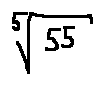Convert formula to latex. <formula><loc_0><loc_0><loc_500><loc_500>\sqrt { [ } 5 ] { 5 5 }</formula> 